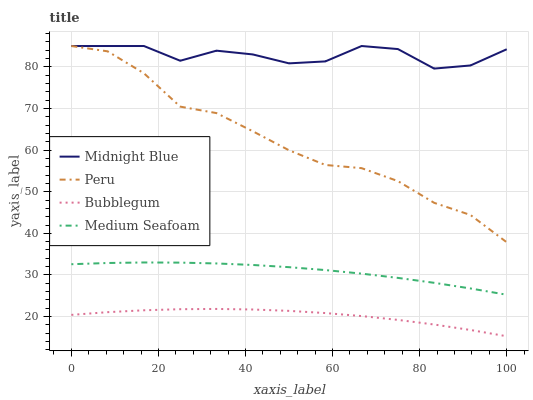Does Bubblegum have the minimum area under the curve?
Answer yes or no. Yes. Does Midnight Blue have the maximum area under the curve?
Answer yes or no. Yes. Does Peru have the minimum area under the curve?
Answer yes or no. No. Does Peru have the maximum area under the curve?
Answer yes or no. No. Is Medium Seafoam the smoothest?
Answer yes or no. Yes. Is Midnight Blue the roughest?
Answer yes or no. Yes. Is Peru the smoothest?
Answer yes or no. No. Is Peru the roughest?
Answer yes or no. No. Does Bubblegum have the lowest value?
Answer yes or no. Yes. Does Peru have the lowest value?
Answer yes or no. No. Does Peru have the highest value?
Answer yes or no. Yes. Does Medium Seafoam have the highest value?
Answer yes or no. No. Is Bubblegum less than Peru?
Answer yes or no. Yes. Is Peru greater than Bubblegum?
Answer yes or no. Yes. Does Peru intersect Midnight Blue?
Answer yes or no. Yes. Is Peru less than Midnight Blue?
Answer yes or no. No. Is Peru greater than Midnight Blue?
Answer yes or no. No. Does Bubblegum intersect Peru?
Answer yes or no. No. 